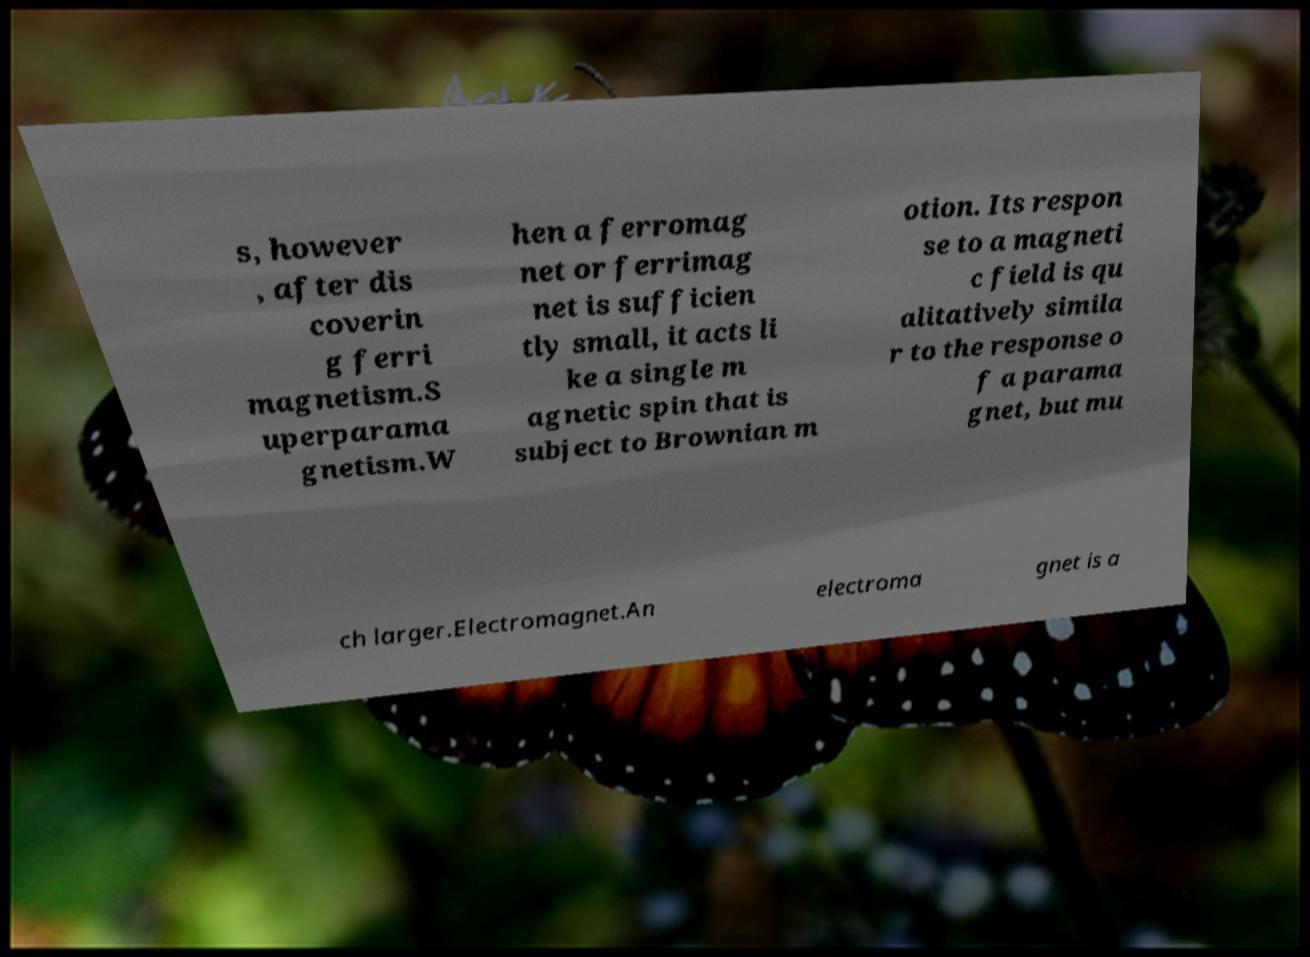For documentation purposes, I need the text within this image transcribed. Could you provide that? s, however , after dis coverin g ferri magnetism.S uperparama gnetism.W hen a ferromag net or ferrimag net is sufficien tly small, it acts li ke a single m agnetic spin that is subject to Brownian m otion. Its respon se to a magneti c field is qu alitatively simila r to the response o f a parama gnet, but mu ch larger.Electromagnet.An electroma gnet is a 